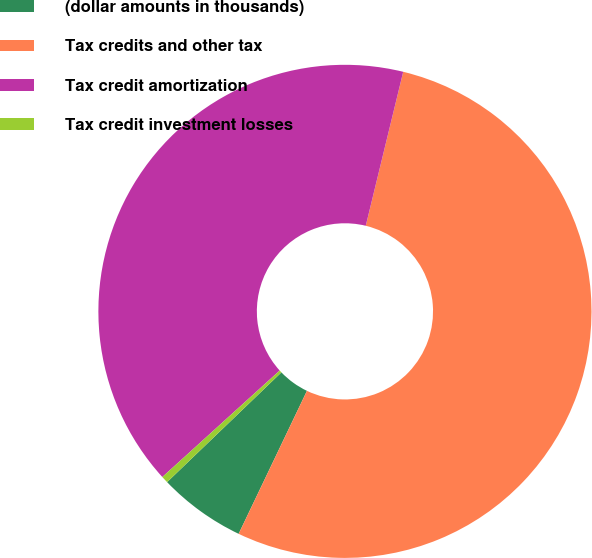Convert chart to OTSL. <chart><loc_0><loc_0><loc_500><loc_500><pie_chart><fcel>(dollar amounts in thousands)<fcel>Tax credits and other tax<fcel>Tax credit amortization<fcel>Tax credit investment losses<nl><fcel>5.73%<fcel>53.29%<fcel>40.52%<fcel>0.45%<nl></chart> 